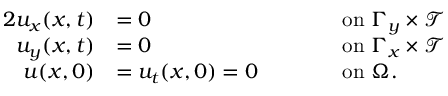<formula> <loc_0><loc_0><loc_500><loc_500>\begin{array} { r l r l } { { 2 } u _ { x } ( x , t ) } & { = 0 } & & { \quad o n \Gamma _ { y } \times \mathcal { T } } \\ { u _ { y } ( x , t ) } & { = 0 } & & { \quad o n \Gamma _ { x } \times \mathcal { T } } \\ { u ( x , 0 ) } & { = u _ { t } ( x , 0 ) = 0 } & & { \quad o n \Omega . } \end{array}</formula> 